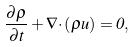<formula> <loc_0><loc_0><loc_500><loc_500>\frac { \partial \rho } { \partial t } + { \nabla \cdot } \left ( \rho { u } \right ) = 0 ,</formula> 